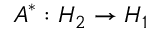<formula> <loc_0><loc_0><loc_500><loc_500>A ^ { * } \colon H _ { 2 } \to H _ { 1 }</formula> 